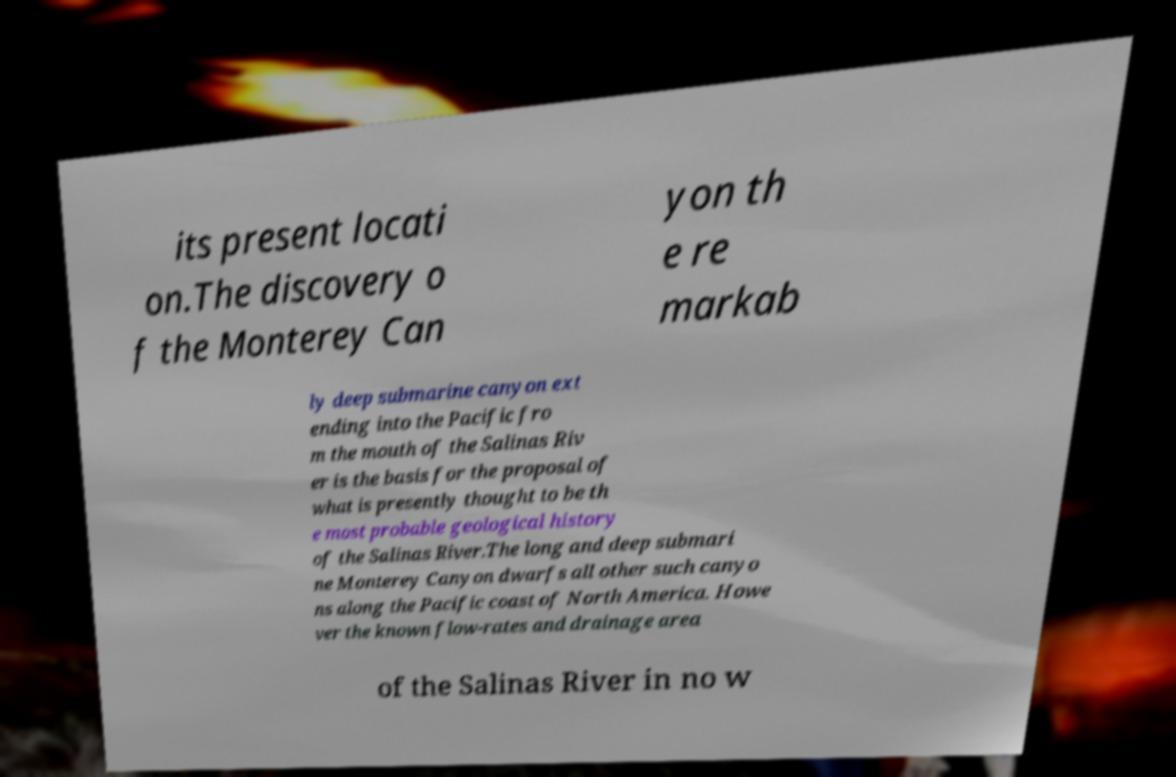Could you assist in decoding the text presented in this image and type it out clearly? its present locati on.The discovery o f the Monterey Can yon th e re markab ly deep submarine canyon ext ending into the Pacific fro m the mouth of the Salinas Riv er is the basis for the proposal of what is presently thought to be th e most probable geological history of the Salinas River.The long and deep submari ne Monterey Canyon dwarfs all other such canyo ns along the Pacific coast of North America. Howe ver the known flow-rates and drainage area of the Salinas River in no w 